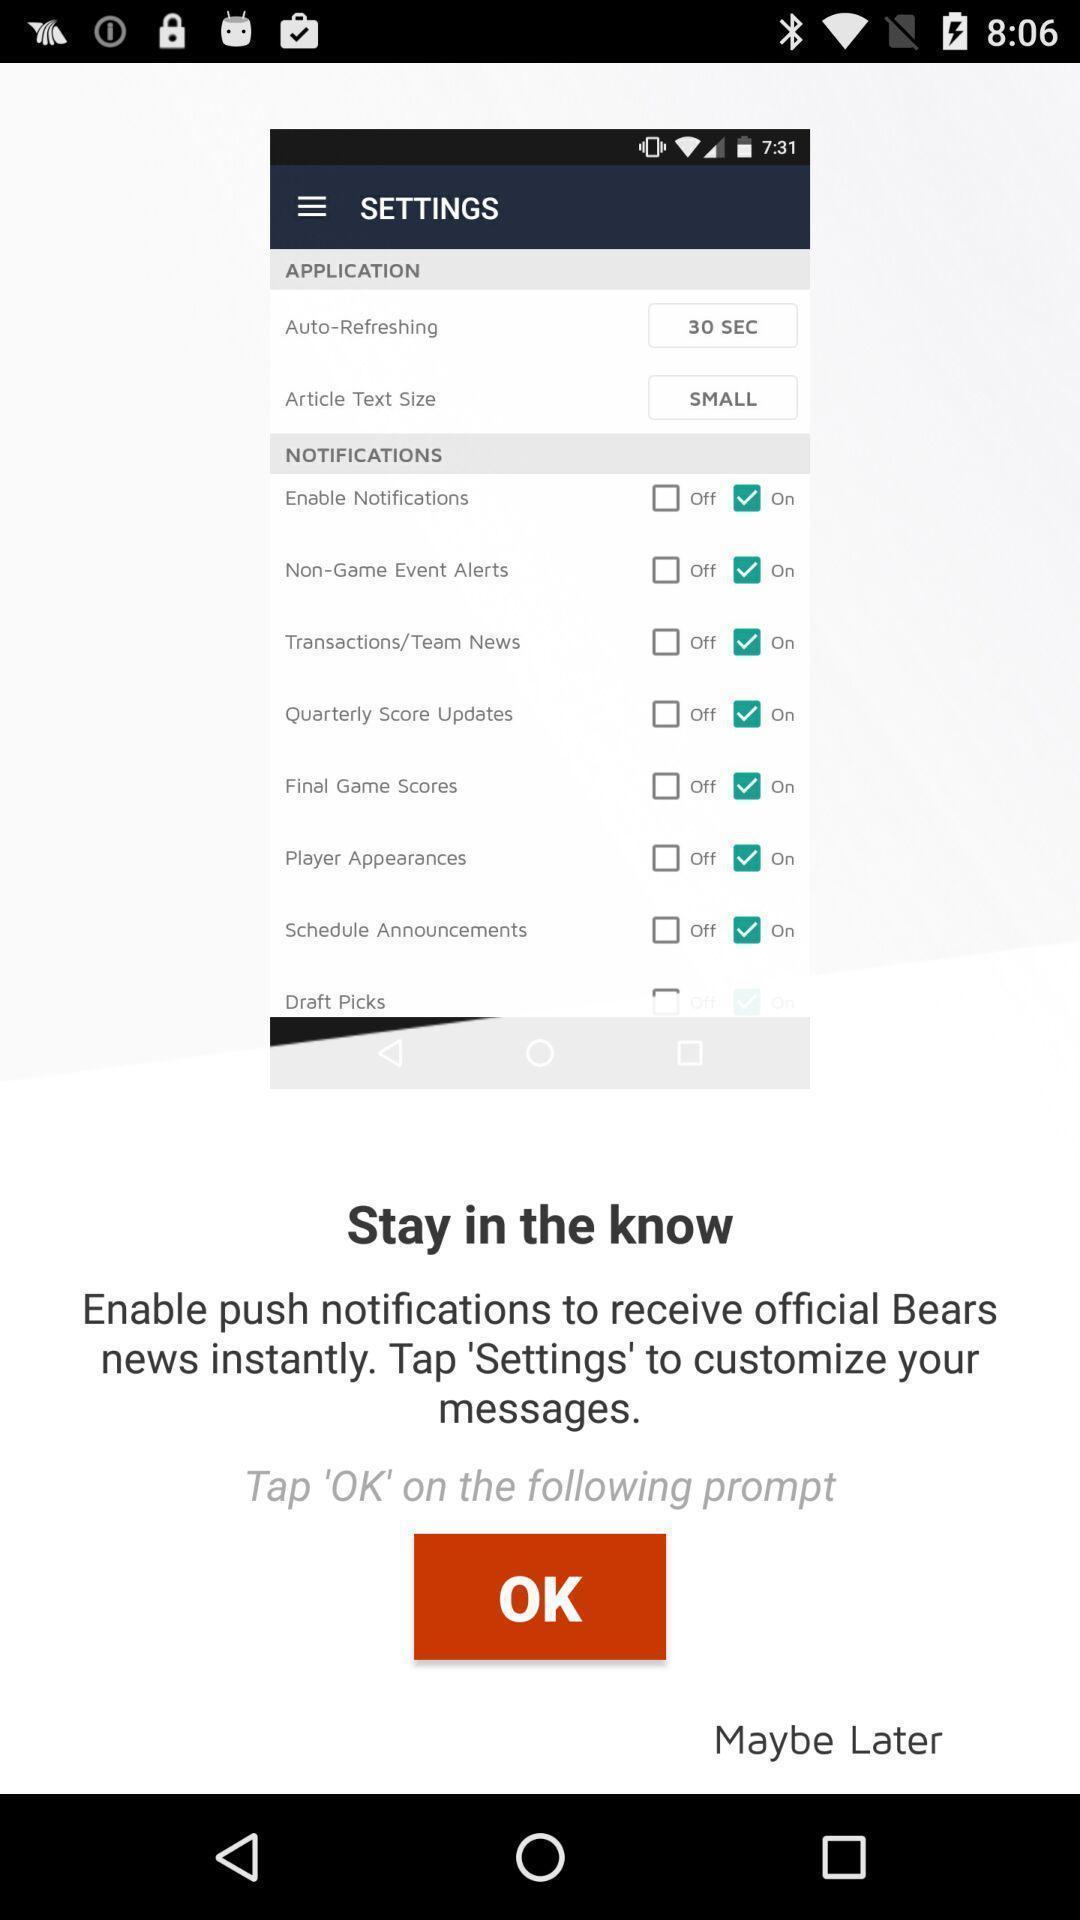Provide a description of this screenshot. Screen showing stay in the know with ok option. 